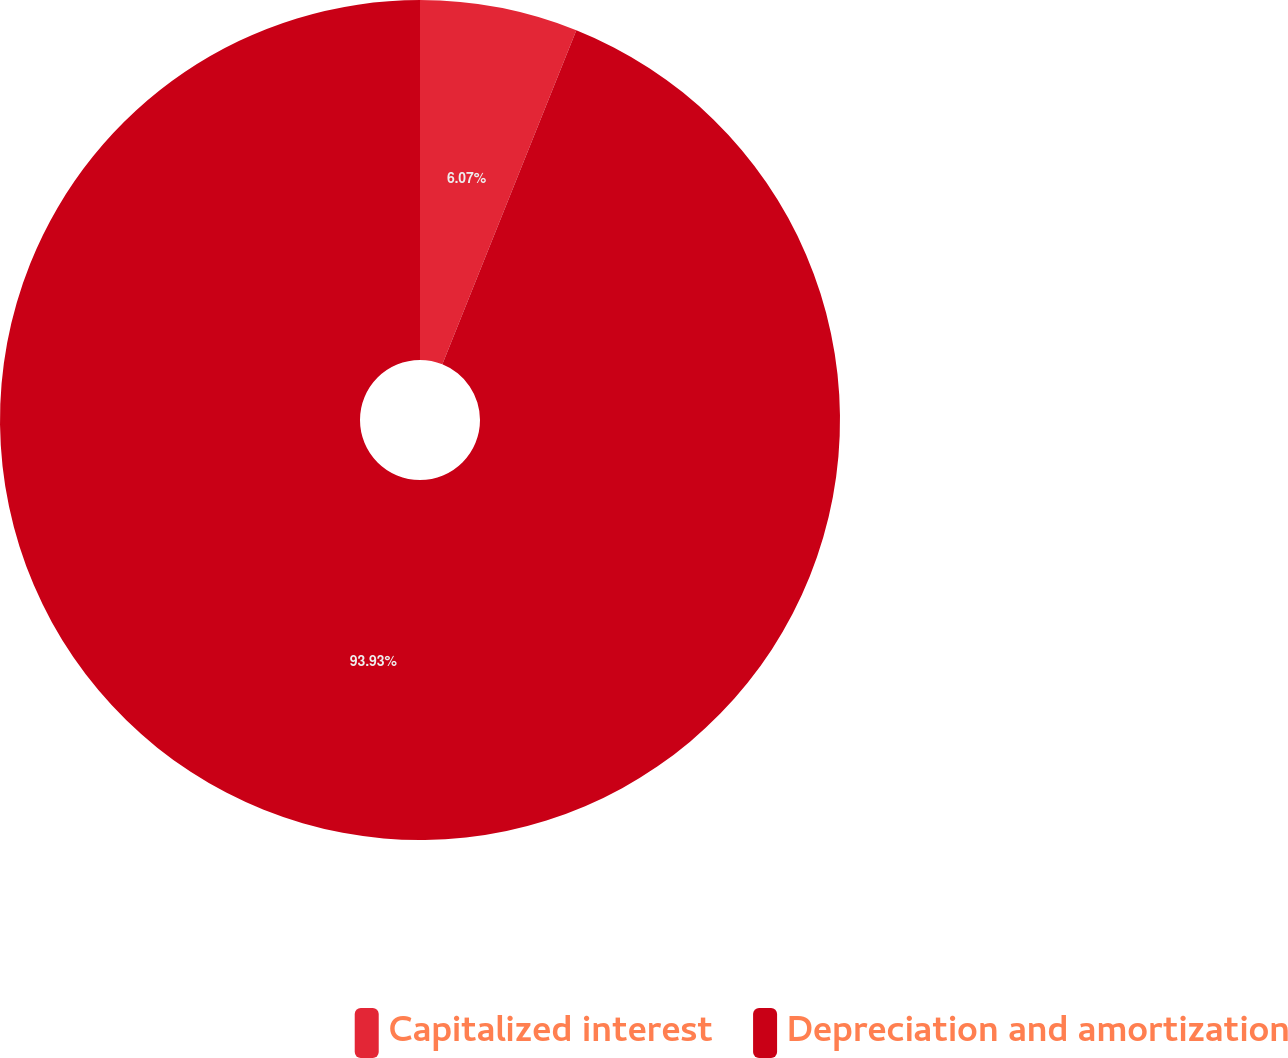Convert chart. <chart><loc_0><loc_0><loc_500><loc_500><pie_chart><fcel>Capitalized interest<fcel>Depreciation and amortization<nl><fcel>6.07%<fcel>93.93%<nl></chart> 